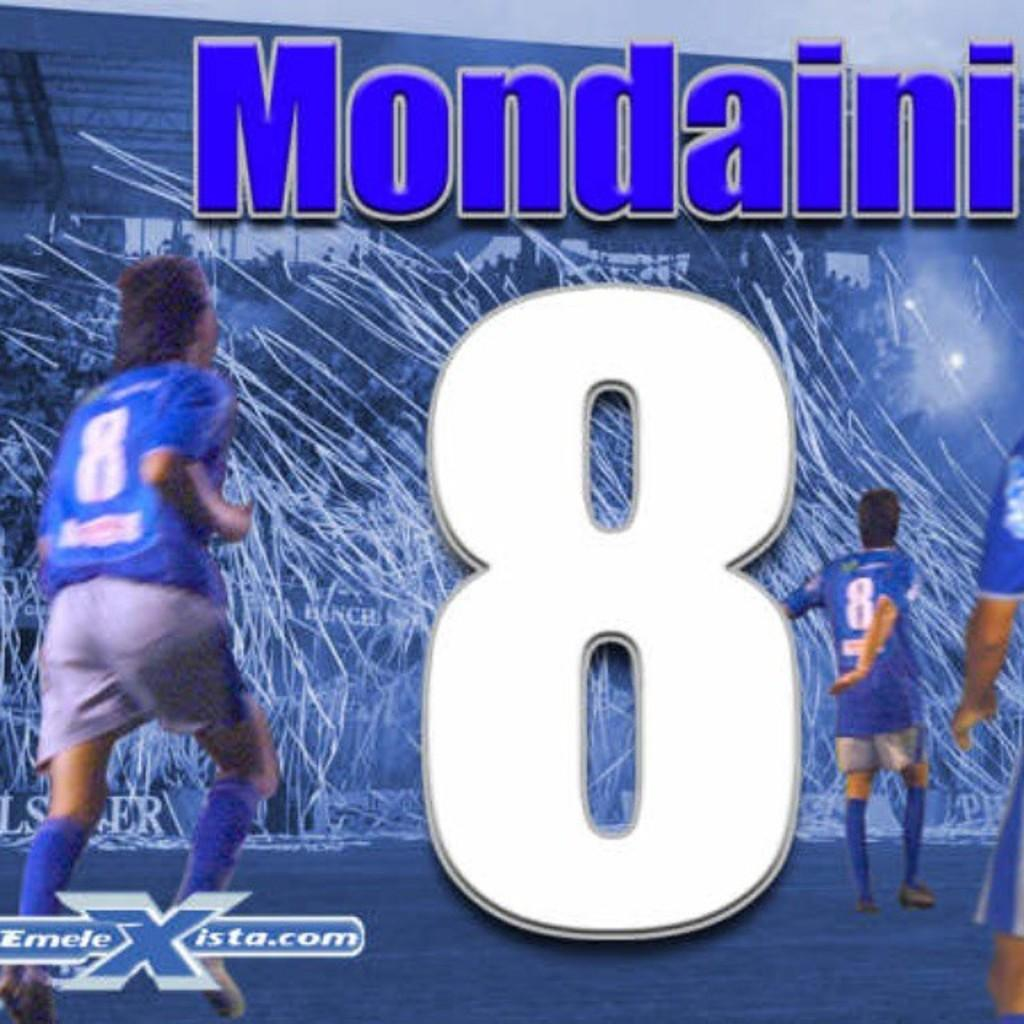How many people are in the image? There are three people in the image. What are the people wearing? The people are wearing blue dresses. What can be seen in the background of the image? The background includes lights and a stadium. Is there any text or writing visible in the image? Yes, there is something written in the image, possibly on the stadium. What type of coat is the spot wearing in the image? There is no spot or coat present in the image. What kind of voyage are the people embarking on in the image? There is no indication of a voyage or journey in the image; it features three people wearing blue dresses in front of a stadium. 